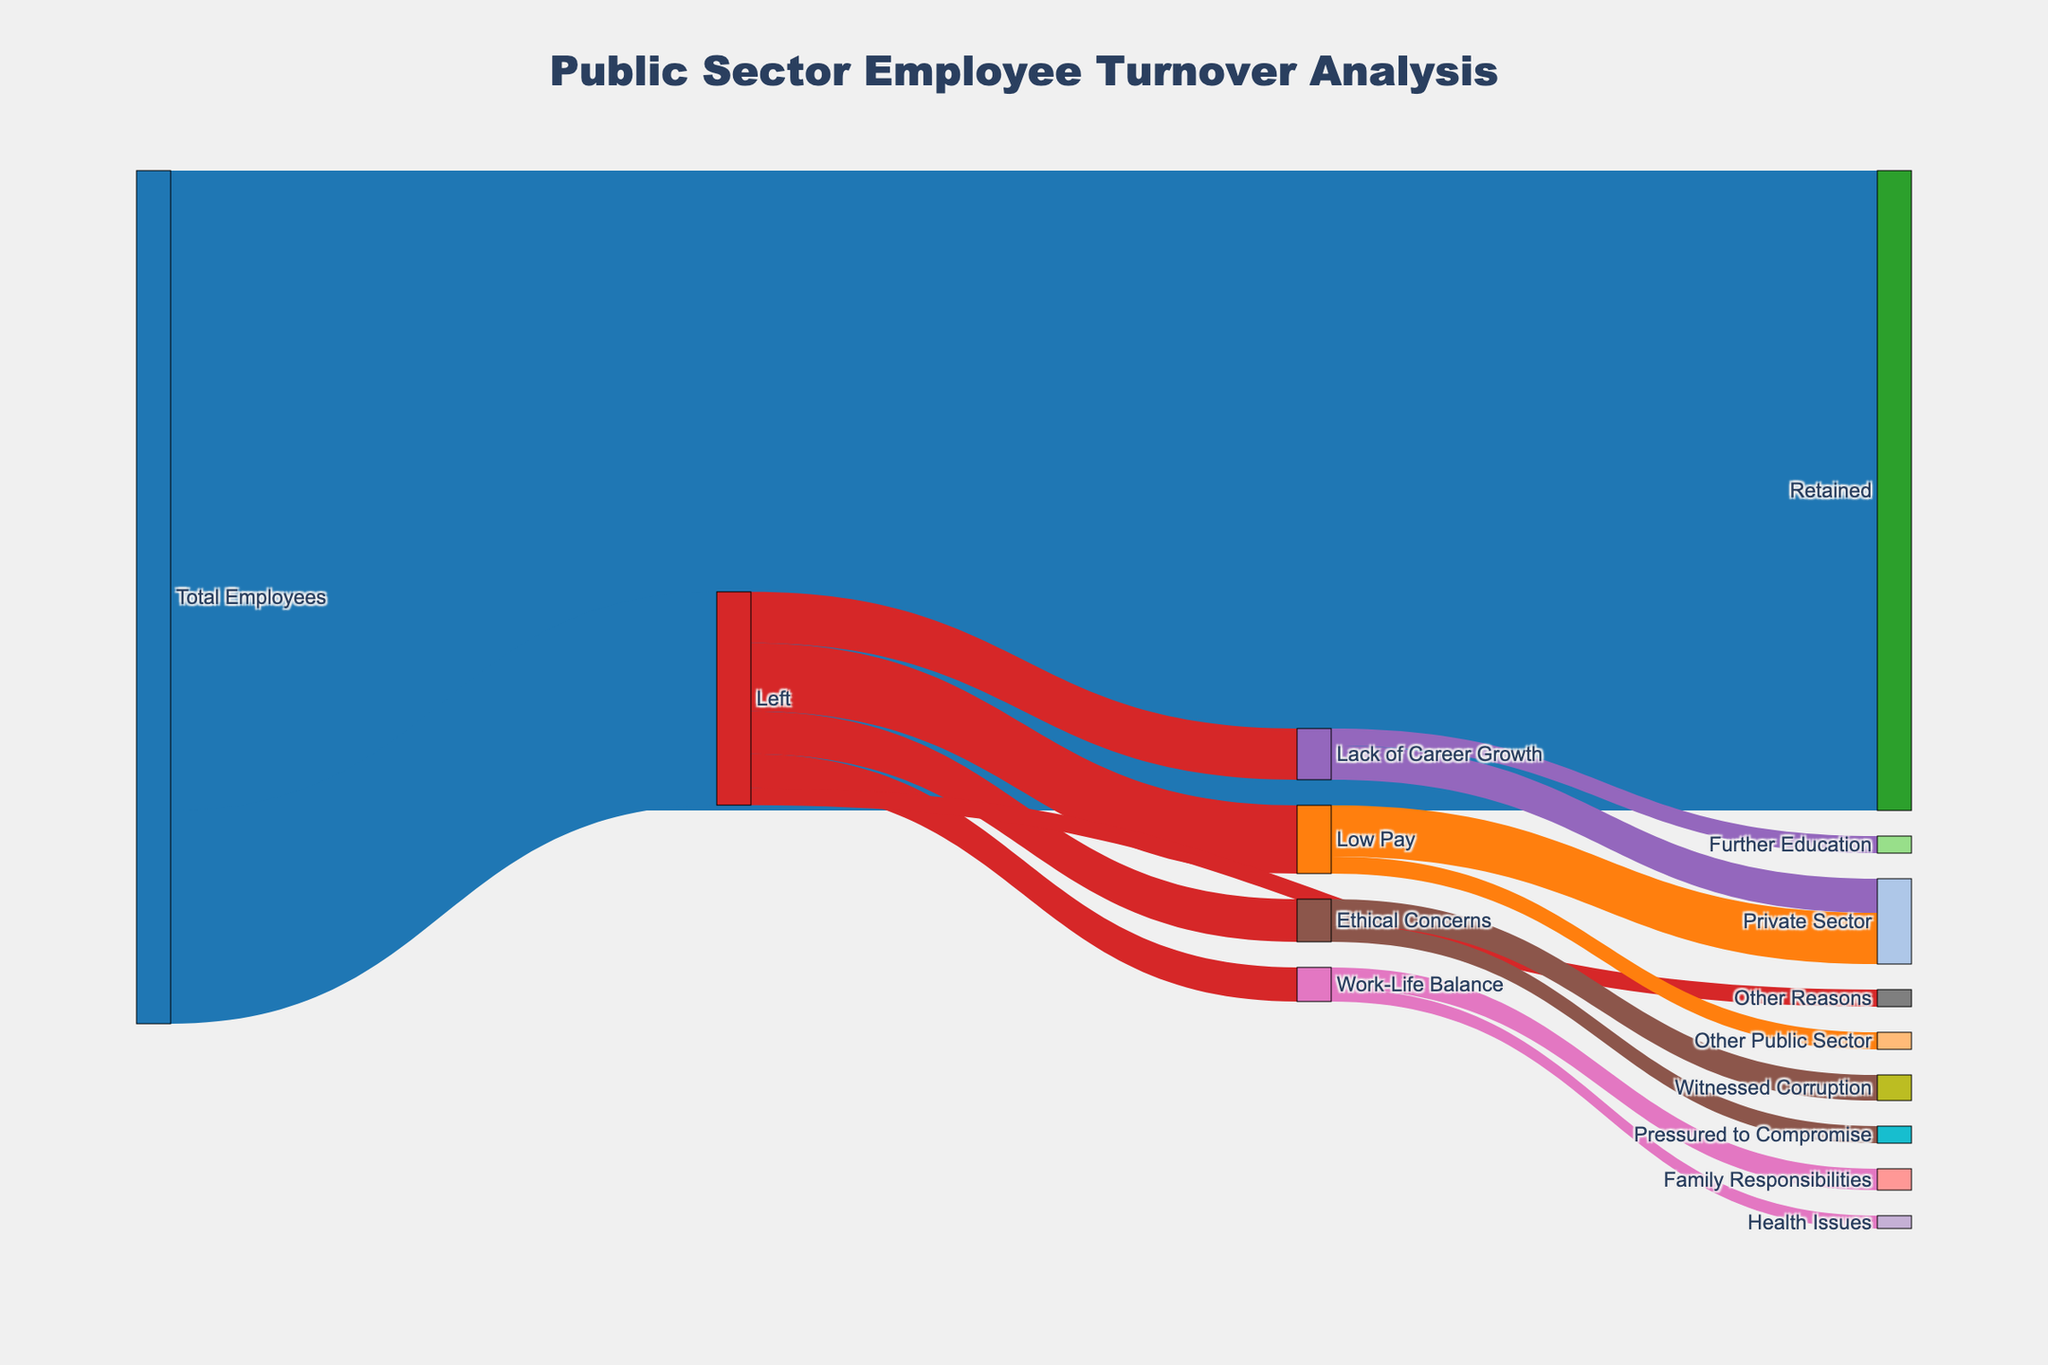How many employees were retained? According to the Sankey diagram, we look for the flow from 'Total Employees' to 'Retained' to find the number 75,000.
Answer: 75,000 Which reason caused the highest employee turnover? To find the reason with the highest turnover, we compare the outgoing flows from 'Left'. The highest value is for 'Low Pay' at 8,000.
Answer: Low Pay What fraction of employees left due to Ethical Concerns? From the Total number of employees who left (25,000), we identify the outflow to 'Ethical Concerns' (5,000). The calculation is 5000/25000 = 0.2 or 20%.
Answer: 20% Which category had a higher turnover to the Private Sector: Low Pay or Lack of Career Growth? We compare the outflows to the 'Private Sector'. 'Low Pay' had 6,000, and 'Lack of Career Growth' had 4,000. 'Low Pay' is higher.
Answer: Low Pay How many employees left due to Work-Life Balance issues? We check the flow from 'Left' to 'Work-Life Balance' which is 4,000.
Answer: 4,000 What percentage of employees who left due to Ethical Concerns witnessed corruption? We divide the number of employees who witnessed corruption (3,000) by the total who left due to Ethical Concerns (5,000). The calculation is 3000/5000 = 0.6 or 60%.
Answer: 60% What is the total number of employees who left for reasons other than Work-Life Balance? From the figure, Work-Life Balance accounts for 4,000 out of 25,000. Subtracting, we get 25,000 - 4,000 = 21,000 left for other reasons.
Answer: 21,000 Compare the number of employees who left due to Family Responsibilities with those who left for Health Issues. Reviewing the outflows from 'Work-Life Balance': 2,500 for Family Responsibilities and 1,500 for Health Issues, Family Responsibilities is higher.
Answer: Family Responsibilities How many employees left for Further Education? We refer to the outflow from 'Lack of Career Growth' to 'Further Education' which is 2,000.
Answer: 2,000 Which specific reason within Ethical Concerns caused fewer turnovers? We compare the parts of the flows from Ethical Concerns: 'Witnessed Corruption' (3,000) and 'Pressured to Compromise' (2,000). 'Pressured to Compromise' is fewer.
Answer: Pressured to Compromise 